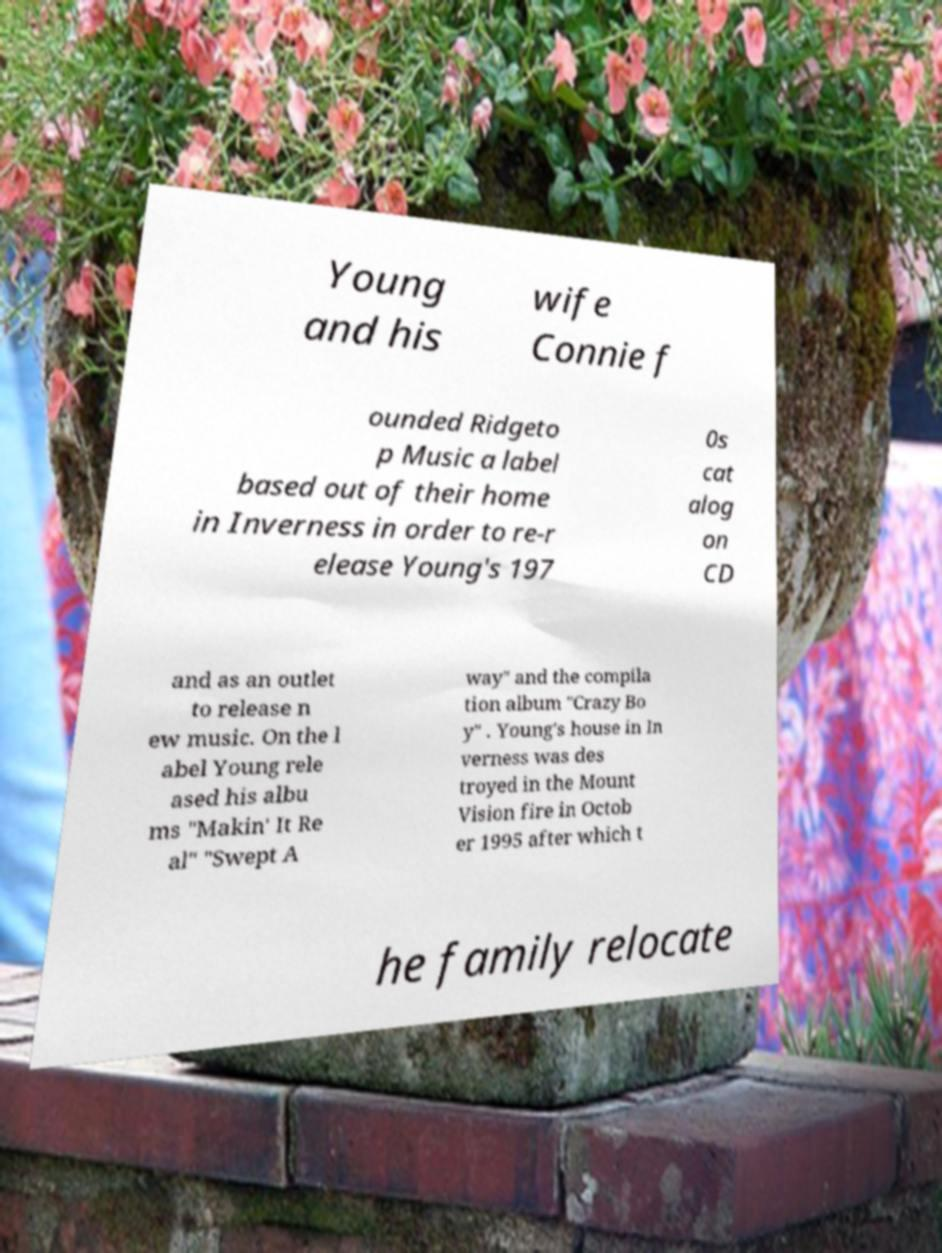There's text embedded in this image that I need extracted. Can you transcribe it verbatim? Young and his wife Connie f ounded Ridgeto p Music a label based out of their home in Inverness in order to re-r elease Young's 197 0s cat alog on CD and as an outlet to release n ew music. On the l abel Young rele ased his albu ms "Makin' It Re al" "Swept A way" and the compila tion album "Crazy Bo y" . Young's house in In verness was des troyed in the Mount Vision fire in Octob er 1995 after which t he family relocate 